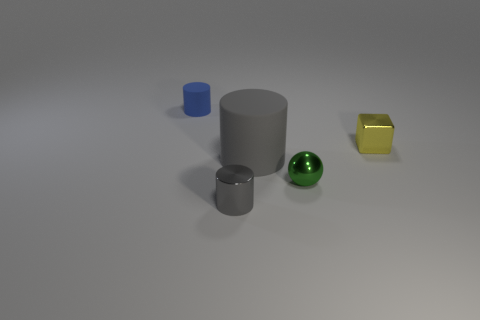What size is the rubber thing that is the same color as the tiny shiny cylinder?
Give a very brief answer. Large. There is a large object that is the same color as the tiny metallic cylinder; what is its shape?
Your answer should be very brief. Cylinder. How many things are tiny blue cylinders or tiny metallic objects that are right of the gray metallic object?
Provide a short and direct response. 3. There is a object behind the block; does it have the same size as the tiny green shiny ball?
Provide a short and direct response. Yes. There is a gray cylinder that is behind the green object; what is its material?
Offer a terse response. Rubber. Is the number of small blue things in front of the metallic cylinder the same as the number of big rubber objects that are behind the tiny yellow metal thing?
Ensure brevity in your answer.  Yes. There is another small object that is the same shape as the blue thing; what is its color?
Ensure brevity in your answer.  Gray. Is there anything else of the same color as the big matte object?
Your answer should be very brief. Yes. How many rubber things are either blue objects or small purple balls?
Keep it short and to the point. 1. Is the shiny cylinder the same color as the big object?
Your answer should be compact. Yes. 